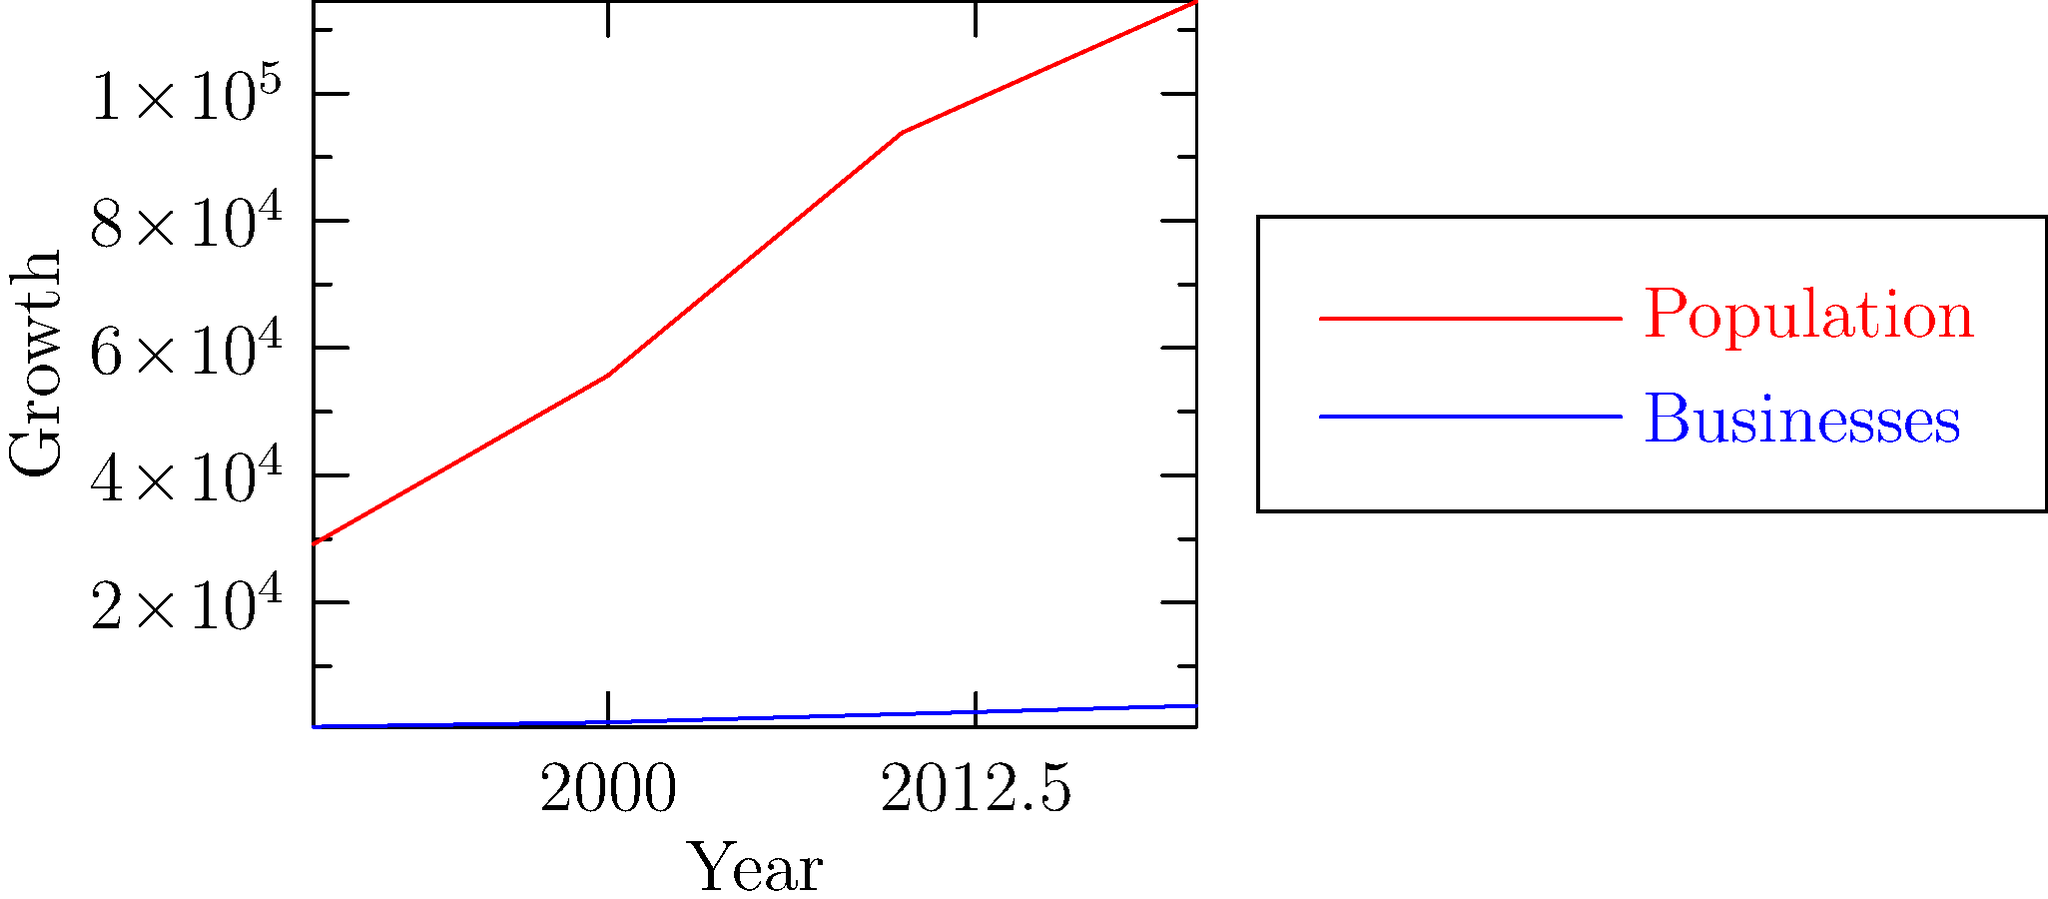Based on the line graph depicting the growth of The Woodlands from 1990 to 2020, what trend can be observed in the relationship between population growth and business growth? To analyze the relationship between population growth and business growth in The Woodlands, let's examine the graph step-by-step:

1. Identify the lines:
   - Red line represents population growth
   - Blue line represents business growth

2. Observe the general trend:
   - Both population and businesses show an upward trend from 1990 to 2020

3. Compare the slopes:
   - The population line has a steeper slope, indicating faster growth
   - The business line shows a more gradual increase

4. Analyze the relationship:
   - As the population increases, the number of businesses also increases
   - However, the rate of increase for businesses is not as rapid as the population growth

5. Consider the implications:
   - The growing population likely creates demand for more businesses
   - The increase in businesses supports the expanding community

6. Conclusion:
   There is a positive correlation between population growth and business growth, with population growing at a faster rate than businesses.

This trend suggests that The Woodlands' economic development is closely tied to its population growth, providing diverse opportunities for stories about the community's expansion and evolution.
Answer: Positive correlation; population grows faster than businesses 